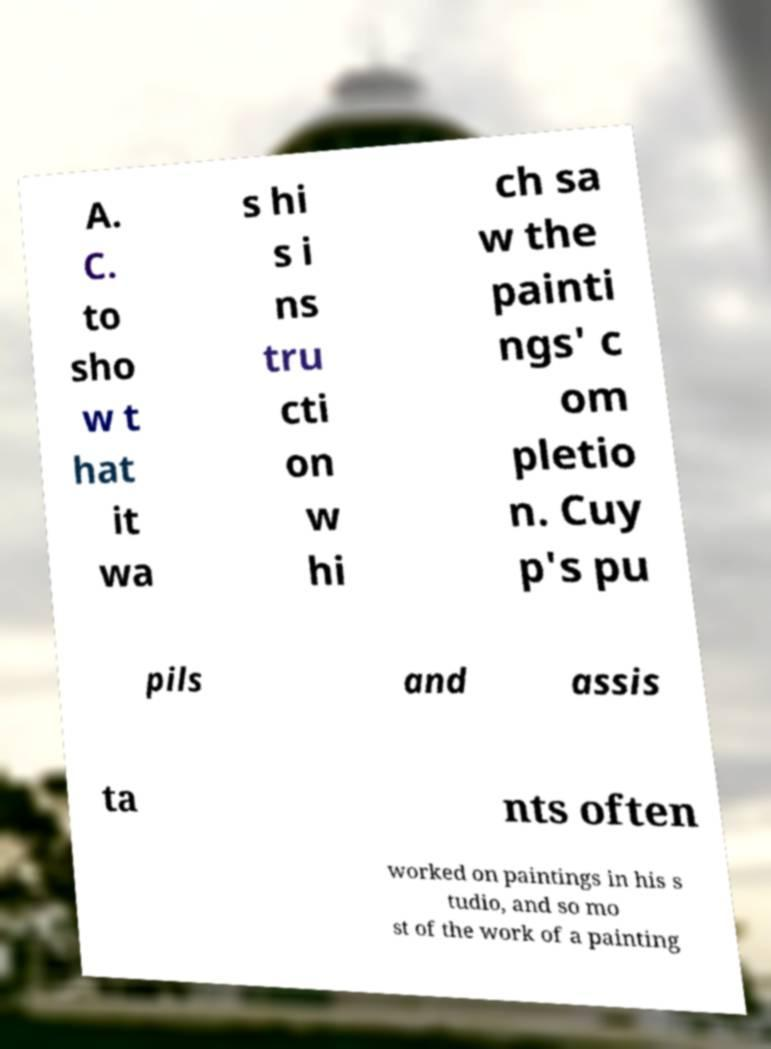Please identify and transcribe the text found in this image. A. C. to sho w t hat it wa s hi s i ns tru cti on w hi ch sa w the painti ngs' c om pletio n. Cuy p's pu pils and assis ta nts often worked on paintings in his s tudio, and so mo st of the work of a painting 